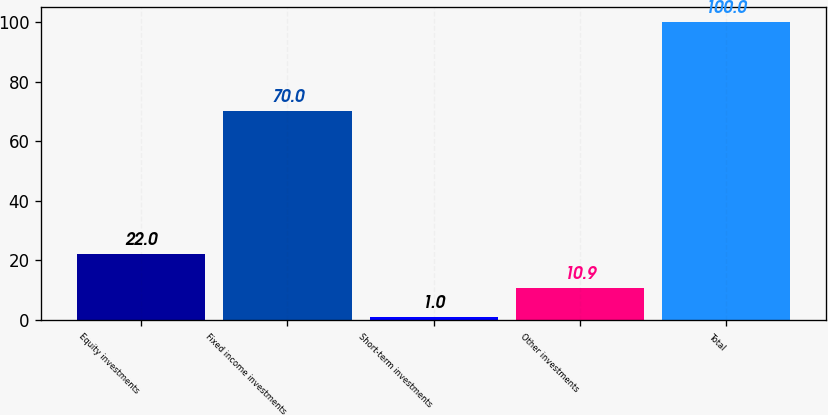<chart> <loc_0><loc_0><loc_500><loc_500><bar_chart><fcel>Equity investments<fcel>Fixed income investments<fcel>Short-term investments<fcel>Other investments<fcel>Total<nl><fcel>22<fcel>70<fcel>1<fcel>10.9<fcel>100<nl></chart> 